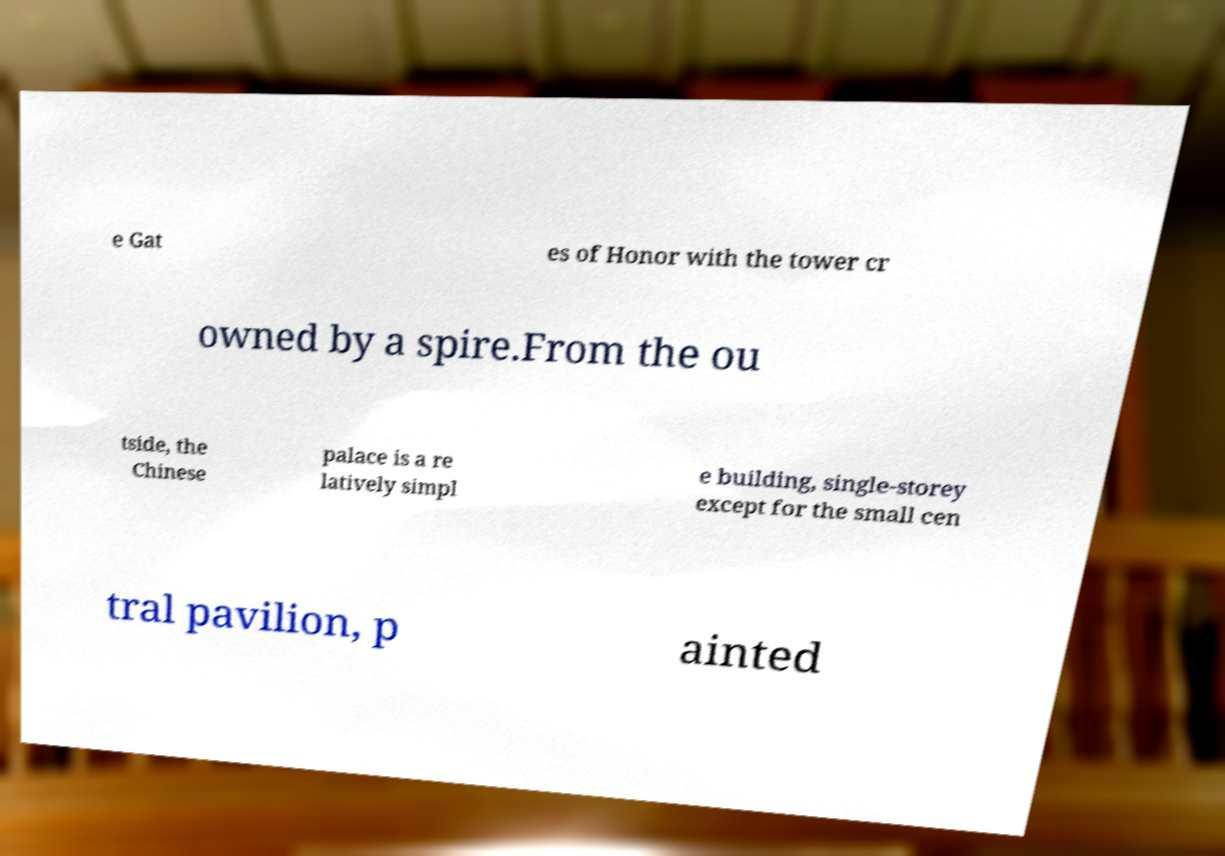What messages or text are displayed in this image? I need them in a readable, typed format. e Gat es of Honor with the tower cr owned by a spire.From the ou tside, the Chinese palace is a re latively simpl e building, single-storey except for the small cen tral pavilion, p ainted 